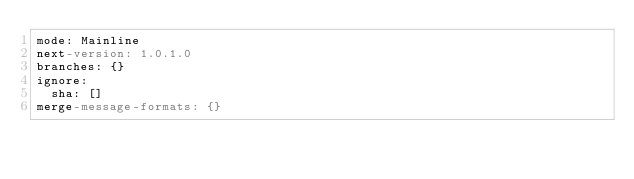<code> <loc_0><loc_0><loc_500><loc_500><_YAML_>mode: Mainline
next-version: 1.0.1.0
branches: {}
ignore:
  sha: []
merge-message-formats: {}
</code> 